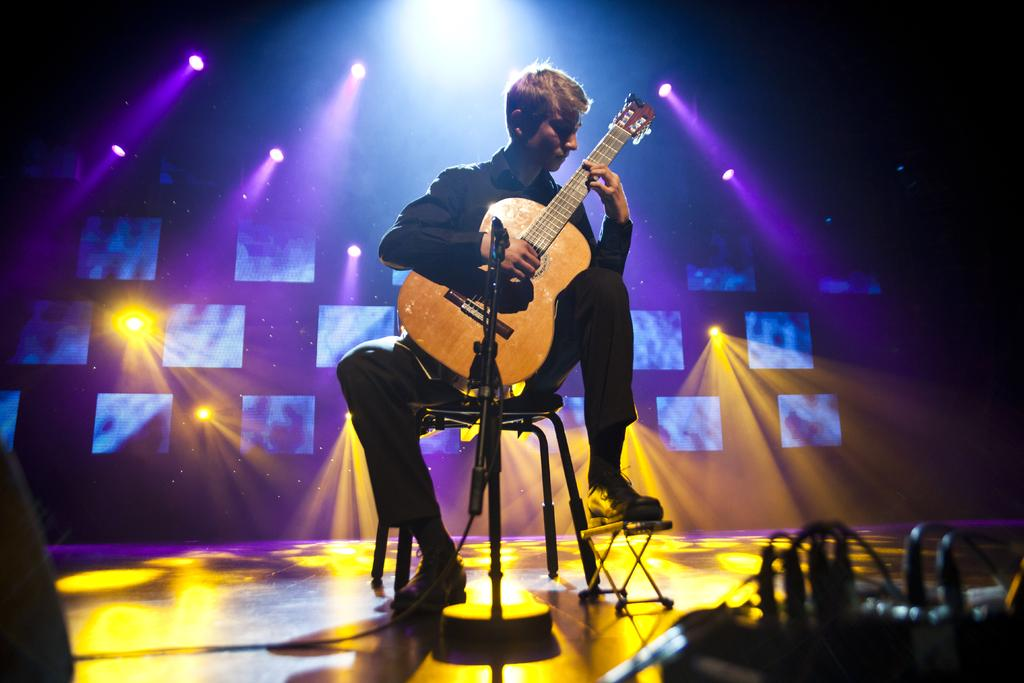What is the main subject of the image? There is a person in the image. What is the person doing in the image? The person is sitting on a chair. What object is the person holding in the image? The person is holding a guitar in his hand. What type of sack can be seen on the person's head in the image? There is no sack present on the person's head in the image. What kind of stick is the person using to play the guitar in the image? The person is not using a stick to play the guitar in the image; they are using their hands. 